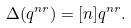<formula> <loc_0><loc_0><loc_500><loc_500>\Delta ( q ^ { n r } ) = [ n ] q ^ { n r } .</formula> 